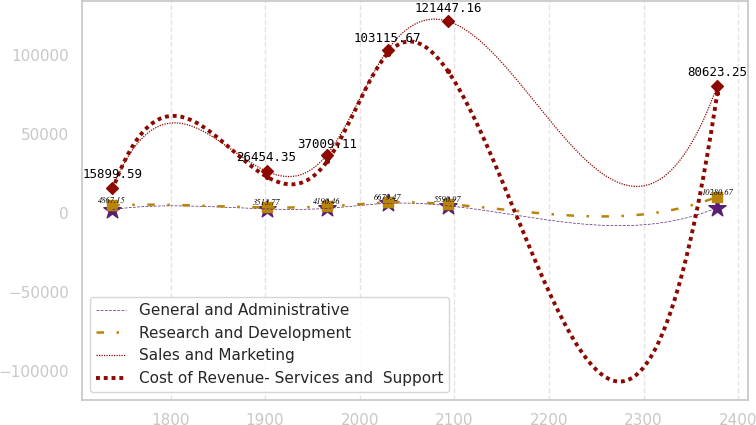Convert chart to OTSL. <chart><loc_0><loc_0><loc_500><loc_500><line_chart><ecel><fcel>General and Administrative<fcel>Research and Development<fcel>Sales and Marketing<fcel>Cost of Revenue- Services and  Support<nl><fcel>1738.48<fcel>2146.2<fcel>4867.15<fcel>15899.6<fcel>14386.8<nl><fcel>1901.49<fcel>2544.19<fcel>3513.77<fcel>26454.3<fcel>23045.7<nl><fcel>1965.43<fcel>2942.18<fcel>4190.46<fcel>37009.1<fcel>32662.4<nl><fcel>2029.37<fcel>6126.07<fcel>6679.47<fcel>103116<fcel>100976<nl><fcel>2093.31<fcel>4611.03<fcel>5590.97<fcel>121447<fcel>89761.2<nl><fcel>2377.88<fcel>3340.17<fcel>10280.7<fcel>80623.2<fcel>75907.6<nl></chart> 